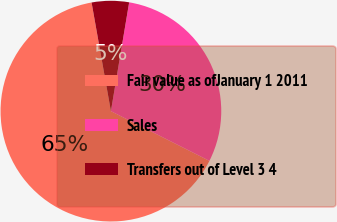Convert chart to OTSL. <chart><loc_0><loc_0><loc_500><loc_500><pie_chart><fcel>Fair value as ofJanuary 1 2011<fcel>Sales<fcel>Transfers out of Level 3 4<nl><fcel>64.76%<fcel>29.79%<fcel>5.45%<nl></chart> 